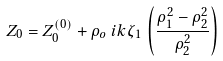<formula> <loc_0><loc_0><loc_500><loc_500>Z _ { 0 } & = Z _ { 0 } ^ { ( 0 ) } + \rho _ { o } \, i k \zeta _ { 1 } \, \left ( \frac { \rho _ { 1 } ^ { 2 } - \rho _ { 2 } ^ { 2 } } { \rho _ { 2 } ^ { 2 } } \right )</formula> 